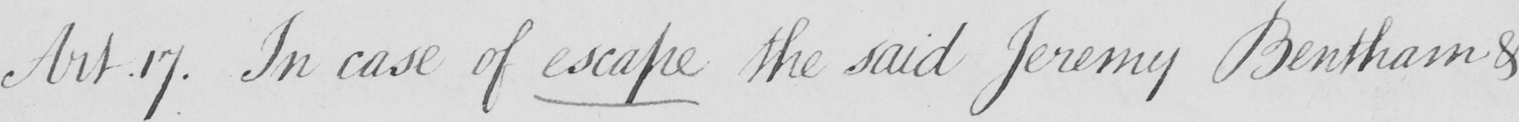Transcribe the text shown in this historical manuscript line. Art . 17 . In case of escape the said Jeremy Bentham & 